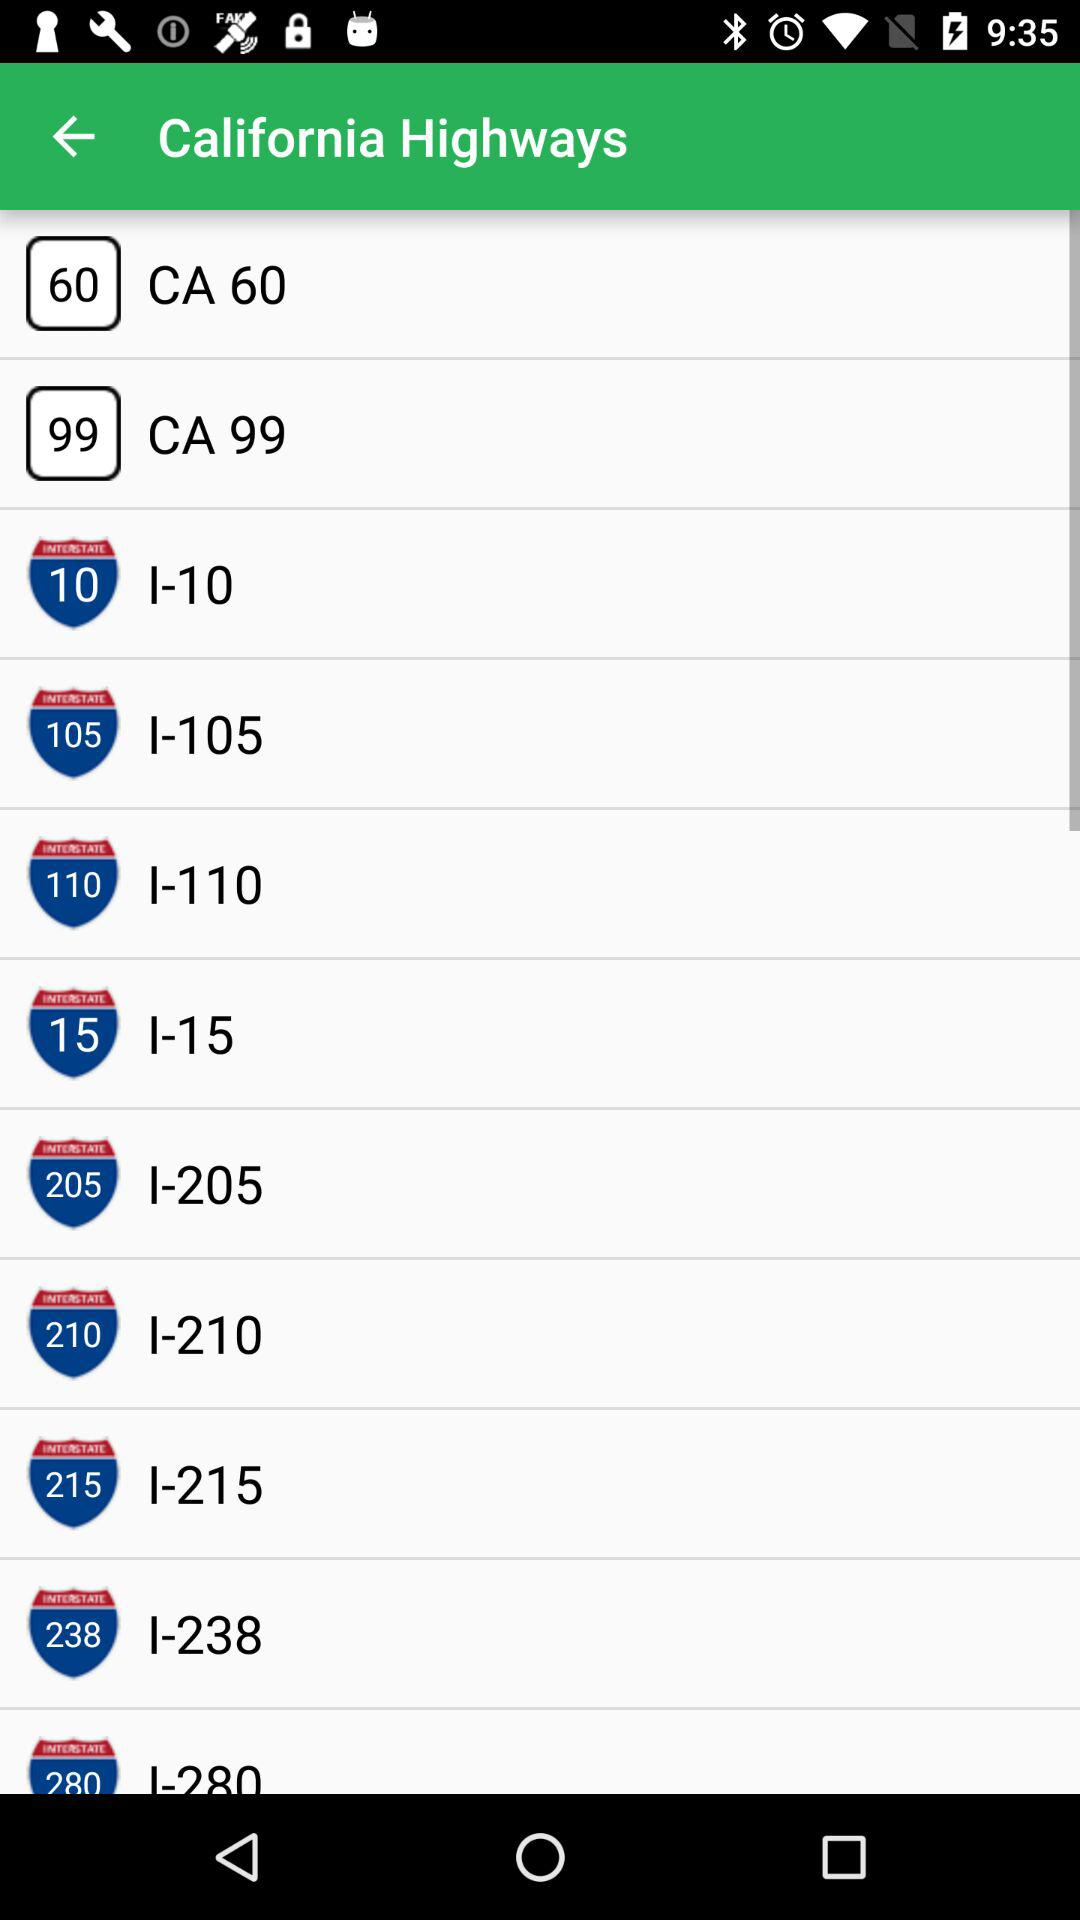Where is the nearest highway?
When the provided information is insufficient, respond with <no answer>. <no answer> 